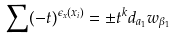<formula> <loc_0><loc_0><loc_500><loc_500>\sum ( - t ) ^ { \epsilon _ { x } ( x _ { i } ) } = \pm t ^ { k } d _ { a _ { 1 } } w _ { \beta _ { 1 } }</formula> 